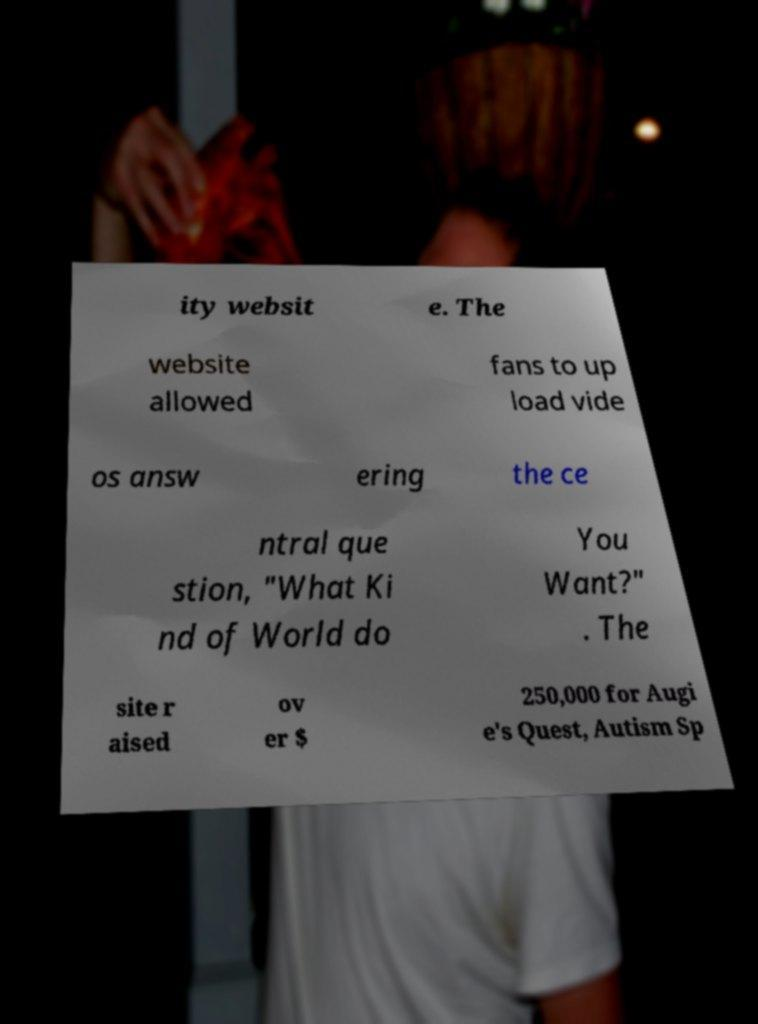Can you read and provide the text displayed in the image?This photo seems to have some interesting text. Can you extract and type it out for me? ity websit e. The website allowed fans to up load vide os answ ering the ce ntral que stion, "What Ki nd of World do You Want?" . The site r aised ov er $ 250,000 for Augi e's Quest, Autism Sp 